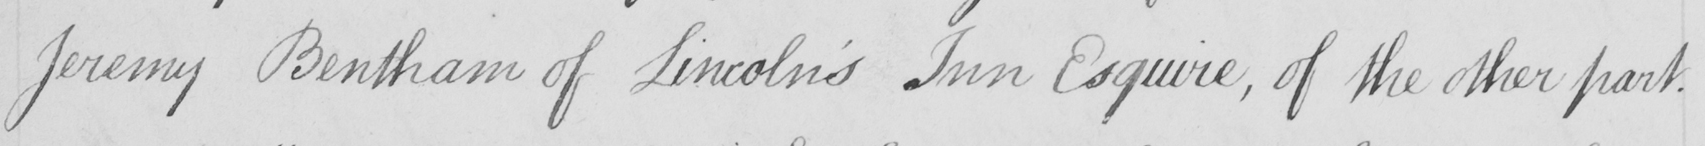What text is written in this handwritten line? Jeremy Benthamm of Lincoln ' s Inn Esquire , of the other part . 